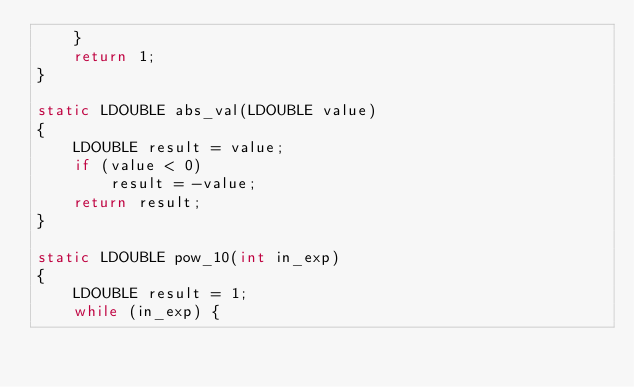<code> <loc_0><loc_0><loc_500><loc_500><_C_>    }
    return 1;
}

static LDOUBLE abs_val(LDOUBLE value)
{
    LDOUBLE result = value;
    if (value < 0)
        result = -value;
    return result;
}

static LDOUBLE pow_10(int in_exp)
{
    LDOUBLE result = 1;
    while (in_exp) {</code> 